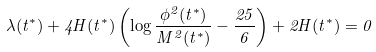Convert formula to latex. <formula><loc_0><loc_0><loc_500><loc_500>\lambda ( t ^ { * } ) + 4 H ( t ^ { * } ) \left ( \log \frac { \phi ^ { 2 } ( t ^ { * } ) } { M ^ { 2 } ( t ^ { * } ) } - \frac { 2 5 } { 6 } \right ) + 2 H ( t ^ { * } ) = 0</formula> 